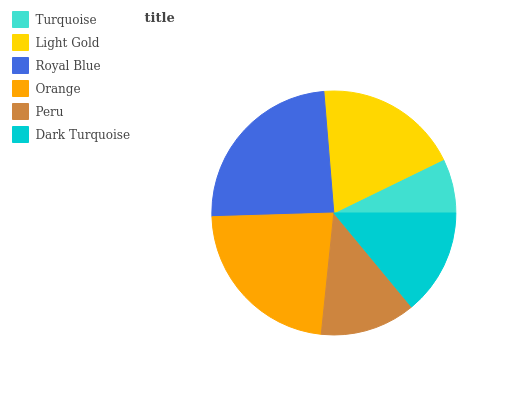Is Turquoise the minimum?
Answer yes or no. Yes. Is Royal Blue the maximum?
Answer yes or no. Yes. Is Light Gold the minimum?
Answer yes or no. No. Is Light Gold the maximum?
Answer yes or no. No. Is Light Gold greater than Turquoise?
Answer yes or no. Yes. Is Turquoise less than Light Gold?
Answer yes or no. Yes. Is Turquoise greater than Light Gold?
Answer yes or no. No. Is Light Gold less than Turquoise?
Answer yes or no. No. Is Light Gold the high median?
Answer yes or no. Yes. Is Dark Turquoise the low median?
Answer yes or no. Yes. Is Royal Blue the high median?
Answer yes or no. No. Is Turquoise the low median?
Answer yes or no. No. 